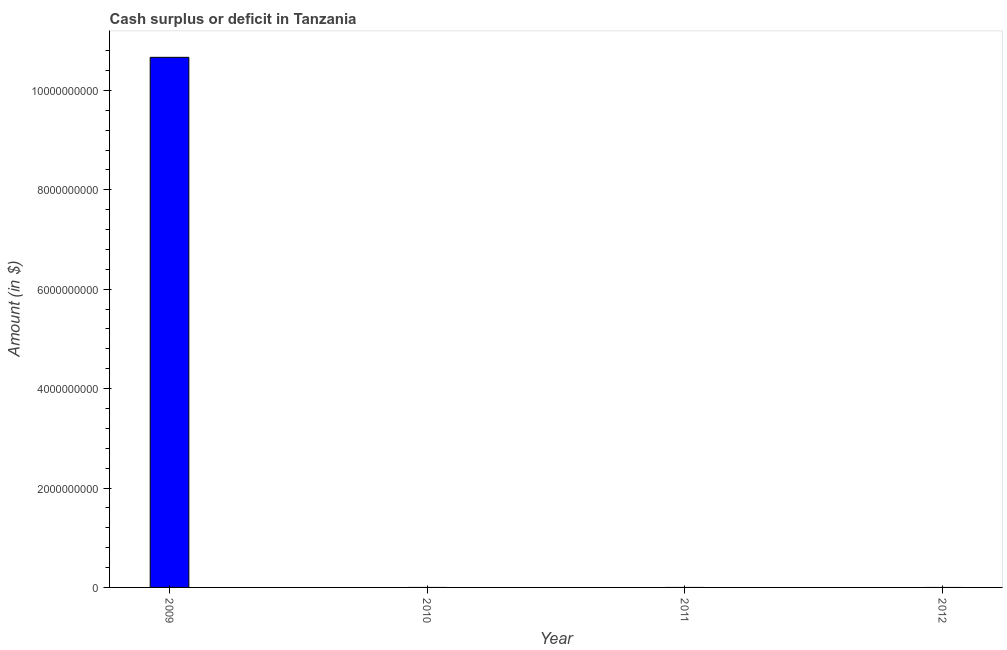Does the graph contain any zero values?
Keep it short and to the point. Yes. What is the title of the graph?
Ensure brevity in your answer.  Cash surplus or deficit in Tanzania. What is the label or title of the Y-axis?
Ensure brevity in your answer.  Amount (in $). What is the cash surplus or deficit in 2011?
Provide a succinct answer. 0. Across all years, what is the maximum cash surplus or deficit?
Offer a terse response. 1.07e+1. Across all years, what is the minimum cash surplus or deficit?
Give a very brief answer. 0. In which year was the cash surplus or deficit maximum?
Offer a very short reply. 2009. What is the sum of the cash surplus or deficit?
Make the answer very short. 1.07e+1. What is the average cash surplus or deficit per year?
Your answer should be compact. 2.67e+09. What is the median cash surplus or deficit?
Ensure brevity in your answer.  0. What is the difference between the highest and the lowest cash surplus or deficit?
Keep it short and to the point. 1.07e+1. In how many years, is the cash surplus or deficit greater than the average cash surplus or deficit taken over all years?
Your answer should be compact. 1. Are all the bars in the graph horizontal?
Keep it short and to the point. No. How many years are there in the graph?
Give a very brief answer. 4. Are the values on the major ticks of Y-axis written in scientific E-notation?
Your answer should be compact. No. What is the Amount (in $) in 2009?
Provide a short and direct response. 1.07e+1. What is the Amount (in $) of 2011?
Ensure brevity in your answer.  0. 